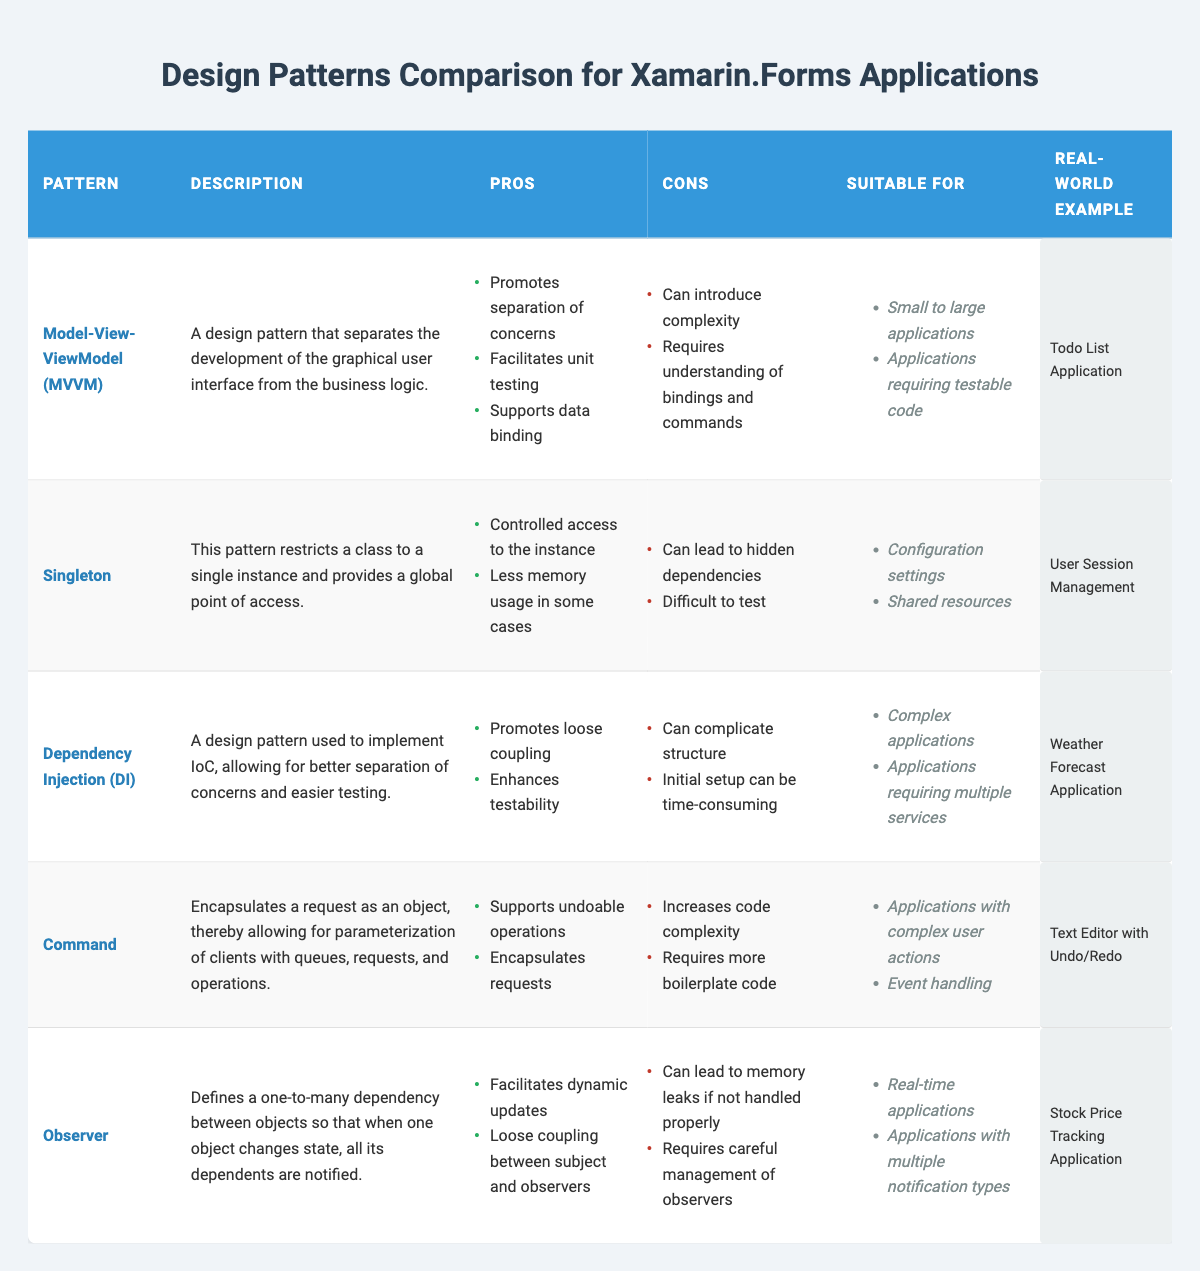What is the description of the Model-View-ViewModel design pattern? The description of the Model-View-ViewModel design pattern is that it separates the development of the graphical user interface from the business logic.
Answer: It separates the GUI from business logic Which design pattern is suitable for applications requiring multiple services? The design pattern suitable for applications requiring multiple services is Dependency Injection (DI), as listed in the 'suitableFor' column.
Answer: Dependency Injection (DI) True or False: The Command pattern is known for requiring less boilerplate code. The Command pattern is known for requiring more boilerplate code as stated in its 'cons' section. Therefore, the statement is false.
Answer: False How many pros does the Observer pattern have? The Observer pattern has two pros as listed in the 'pros' section: facilitates dynamic updates and loose coupling between subject and observers. Countable directly from the table provides the answer.
Answer: Two Which design patterns share the same suitability for small to large applications? Both Model-View-ViewModel (MVVM) and Dependency Injection patterns share the same suitability for small to large applications. This can be obtained by checking the 'suitableFor' sections for each pattern.
Answer: MVVM and Dependency Injection What is the real-world example given for the Command pattern? The real-world example given for the Command pattern is a Text Editor with Undo/Redo functionality, which is specified in the 'realWorldExample' column.
Answer: Text Editor with Undo/Redo Identify the design pattern that has the least pros. The Singleton design pattern has only two pros listed, which is the least compared to others, making it identifiable by comparing the number of pros across the patterns.
Answer: Singleton What is the common drawback cited for both the Singleton and Dependency Injection patterns? The common drawback cited for both the Singleton and Dependency Injection patterns is that both can introduce complexity, as indicated in the 'cons' section of both patterns.
Answer: Can introduce complexity True or False: Real-time applications can utilize the Observer pattern. The Observer pattern is explicitly listed as suitable for real-time applications in the 'suitableFor' section, confirming the statement as true.
Answer: True 